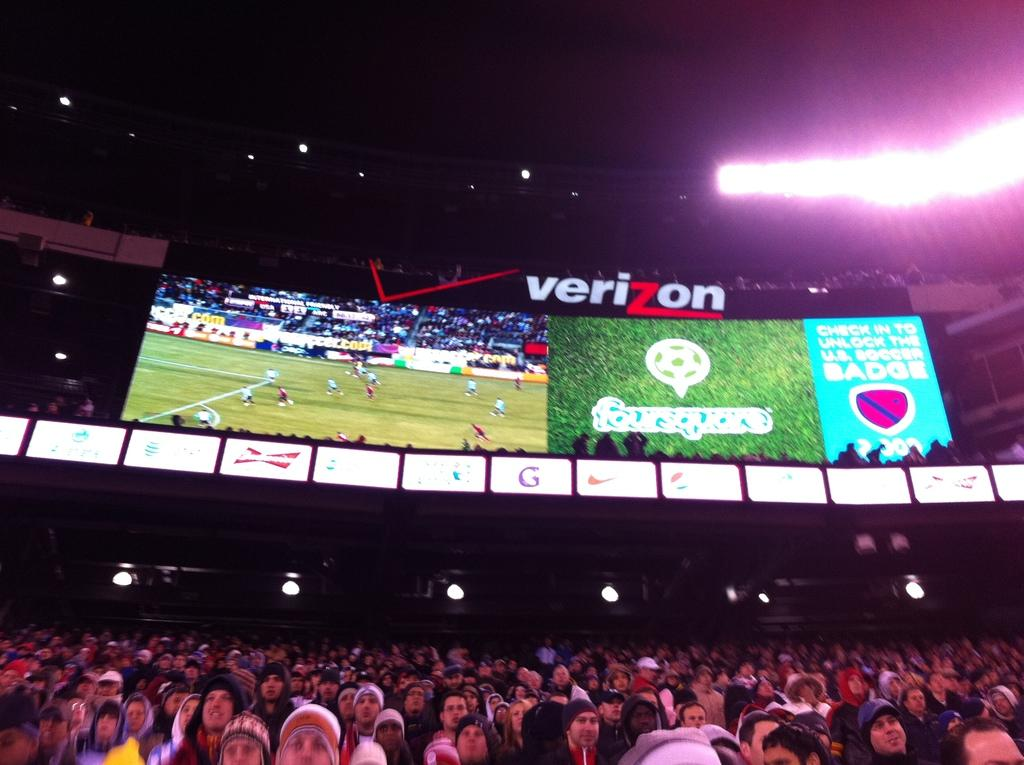<image>
Write a terse but informative summary of the picture. A sports stadium full of people with an ad for Verizon on the screen 